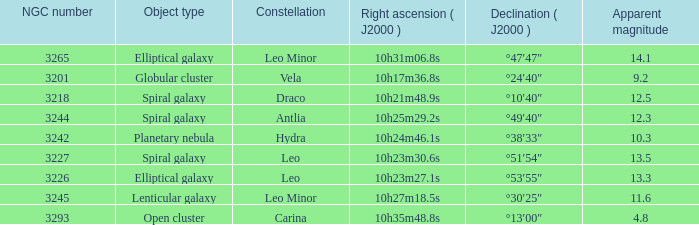What is the Apparent magnitude of a globular cluster? 9.2. 